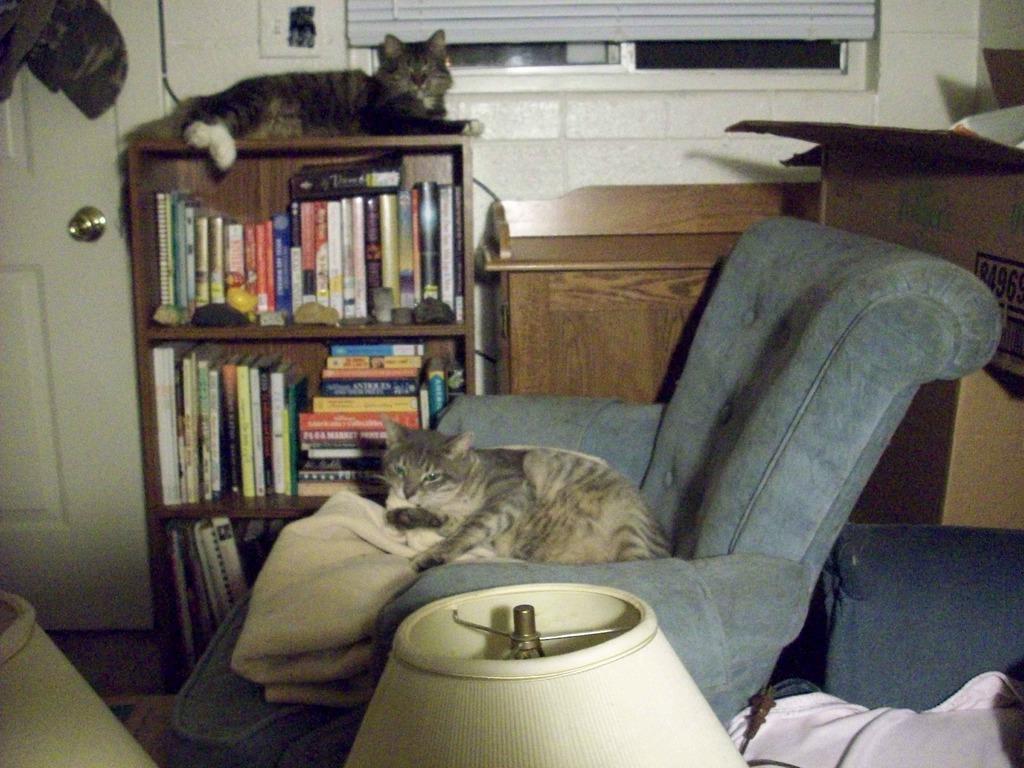In one or two sentences, can you explain what this image depicts? On the background of the picture we can see partial part of the window, a white color wall and a door in white colour. Here we can see crack in which books are arranged in a sequence manner and we can see a cat on the rack. Here we can see a chair and a cat on it. This is a box. 